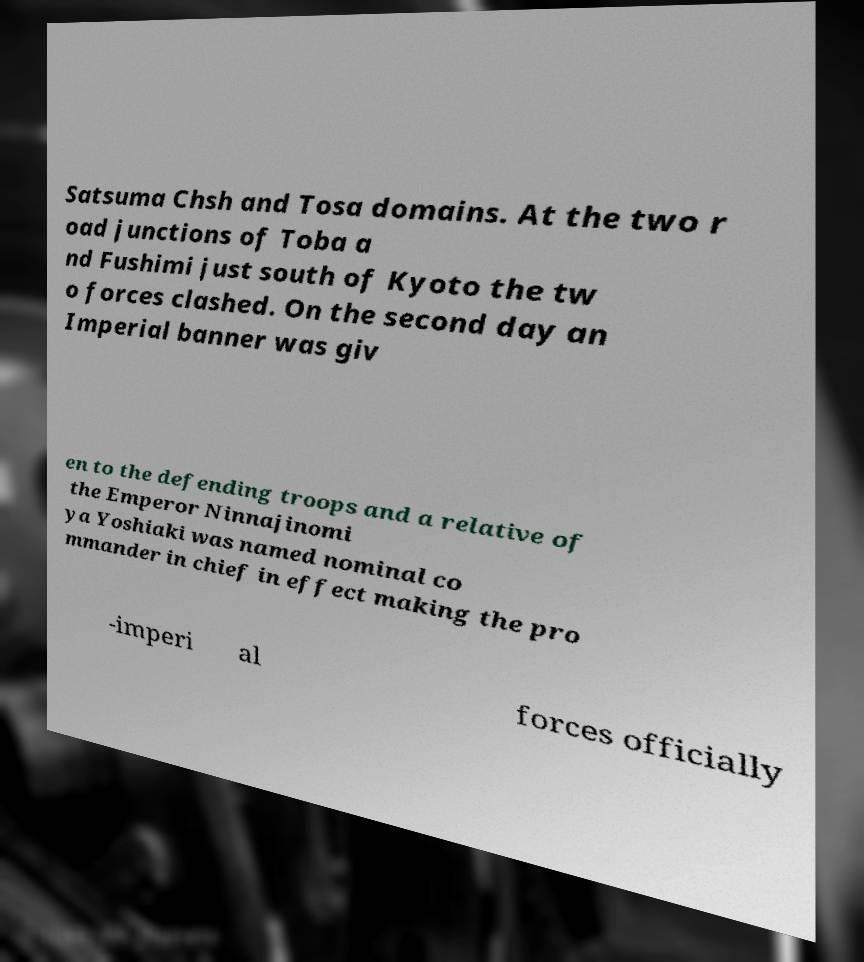Could you assist in decoding the text presented in this image and type it out clearly? Satsuma Chsh and Tosa domains. At the two r oad junctions of Toba a nd Fushimi just south of Kyoto the tw o forces clashed. On the second day an Imperial banner was giv en to the defending troops and a relative of the Emperor Ninnajinomi ya Yoshiaki was named nominal co mmander in chief in effect making the pro -imperi al forces officially 